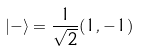<formula> <loc_0><loc_0><loc_500><loc_500>| - \rangle = \frac { 1 } { \sqrt { 2 } } ( 1 , - 1 )</formula> 